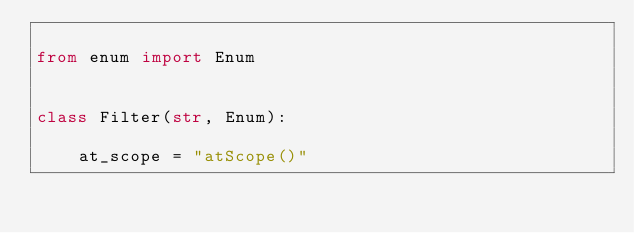Convert code to text. <code><loc_0><loc_0><loc_500><loc_500><_Python_>
from enum import Enum


class Filter(str, Enum):

    at_scope = "atScope()"
</code> 